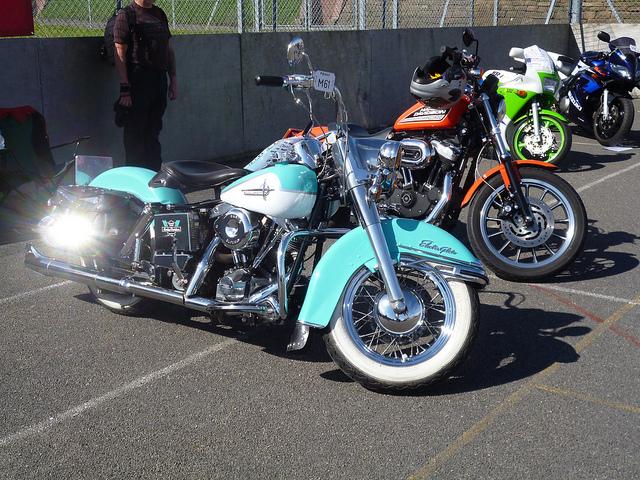What kind of motorcycles are these?
Write a very short answer. Harley. Are all of the bikes different colors?
Write a very short answer. Yes. What would you call this event?
Be succinct. Motorcycle show. Are these bikes parked?
Quick response, please. Yes. 